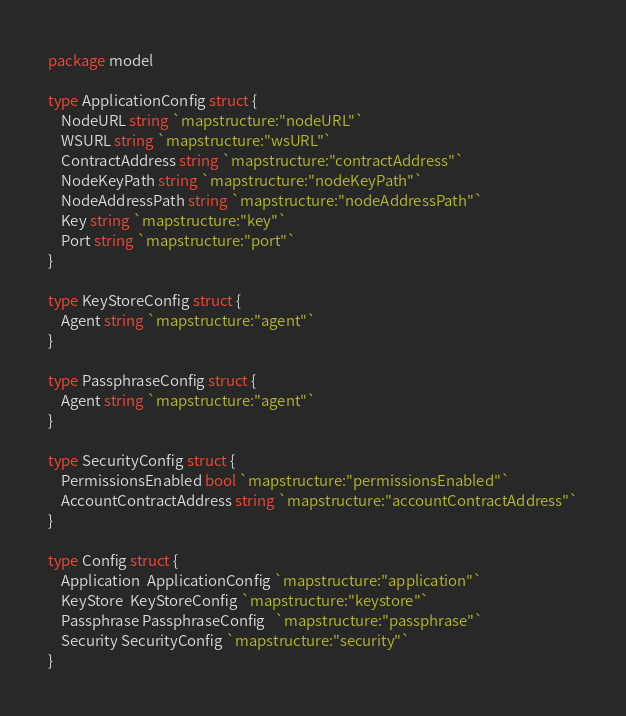Convert code to text. <code><loc_0><loc_0><loc_500><loc_500><_Go_>package model

type ApplicationConfig struct {
	NodeURL string `mapstructure:"nodeURL"`
	WSURL string `mapstructure:"wsURL"`
	ContractAddress string `mapstructure:"contractAddress"`
	NodeKeyPath string `mapstructure:"nodeKeyPath"`
	NodeAddressPath string `mapstructure:"nodeAddressPath"`
	Key string `mapstructure:"key"`
	Port string `mapstructure:"port"`
}

type KeyStoreConfig struct {
	Agent string `mapstructure:"agent"`
}

type PassphraseConfig struct {
	Agent string `mapstructure:"agent"`
}

type SecurityConfig struct {
	PermissionsEnabled bool `mapstructure:"permissionsEnabled"`
	AccountContractAddress string `mapstructure:"accountContractAddress"`
}

type Config struct {
	Application  ApplicationConfig `mapstructure:"application"`
	KeyStore  KeyStoreConfig `mapstructure:"keystore"`
	Passphrase PassphraseConfig   `mapstructure:"passphrase"`
	Security SecurityConfig `mapstructure:"security"`
}</code> 